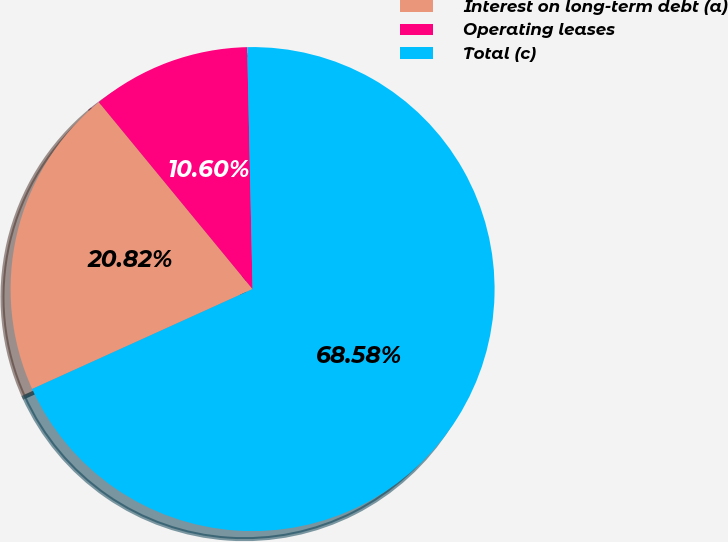<chart> <loc_0><loc_0><loc_500><loc_500><pie_chart><fcel>Interest on long-term debt (a)<fcel>Operating leases<fcel>Total (c)<nl><fcel>20.82%<fcel>10.6%<fcel>68.58%<nl></chart> 